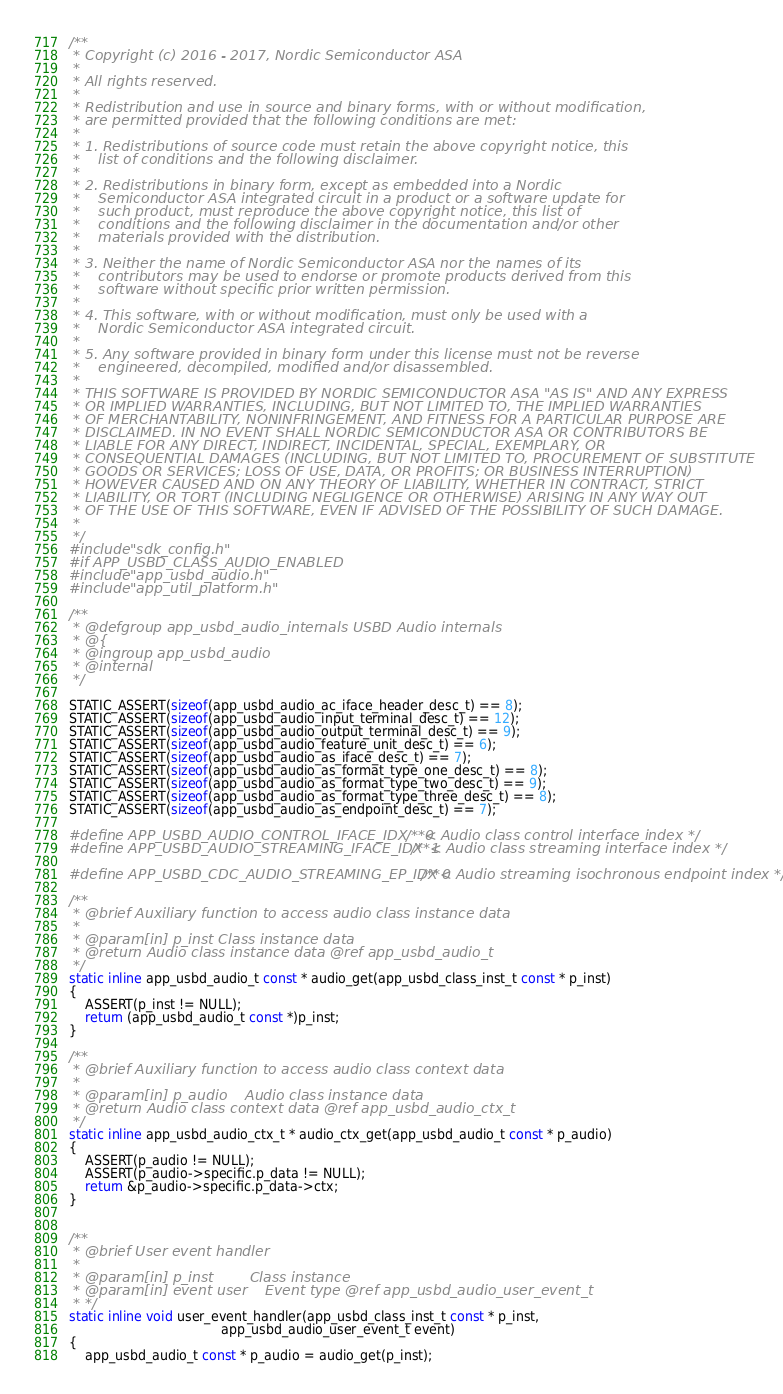<code> <loc_0><loc_0><loc_500><loc_500><_C_>/**
 * Copyright (c) 2016 - 2017, Nordic Semiconductor ASA
 * 
 * All rights reserved.
 * 
 * Redistribution and use in source and binary forms, with or without modification,
 * are permitted provided that the following conditions are met:
 * 
 * 1. Redistributions of source code must retain the above copyright notice, this
 *    list of conditions and the following disclaimer.
 * 
 * 2. Redistributions in binary form, except as embedded into a Nordic
 *    Semiconductor ASA integrated circuit in a product or a software update for
 *    such product, must reproduce the above copyright notice, this list of
 *    conditions and the following disclaimer in the documentation and/or other
 *    materials provided with the distribution.
 * 
 * 3. Neither the name of Nordic Semiconductor ASA nor the names of its
 *    contributors may be used to endorse or promote products derived from this
 *    software without specific prior written permission.
 * 
 * 4. This software, with or without modification, must only be used with a
 *    Nordic Semiconductor ASA integrated circuit.
 * 
 * 5. Any software provided in binary form under this license must not be reverse
 *    engineered, decompiled, modified and/or disassembled.
 * 
 * THIS SOFTWARE IS PROVIDED BY NORDIC SEMICONDUCTOR ASA "AS IS" AND ANY EXPRESS
 * OR IMPLIED WARRANTIES, INCLUDING, BUT NOT LIMITED TO, THE IMPLIED WARRANTIES
 * OF MERCHANTABILITY, NONINFRINGEMENT, AND FITNESS FOR A PARTICULAR PURPOSE ARE
 * DISCLAIMED. IN NO EVENT SHALL NORDIC SEMICONDUCTOR ASA OR CONTRIBUTORS BE
 * LIABLE FOR ANY DIRECT, INDIRECT, INCIDENTAL, SPECIAL, EXEMPLARY, OR
 * CONSEQUENTIAL DAMAGES (INCLUDING, BUT NOT LIMITED TO, PROCUREMENT OF SUBSTITUTE
 * GOODS OR SERVICES; LOSS OF USE, DATA, OR PROFITS; OR BUSINESS INTERRUPTION)
 * HOWEVER CAUSED AND ON ANY THEORY OF LIABILITY, WHETHER IN CONTRACT, STRICT
 * LIABILITY, OR TORT (INCLUDING NEGLIGENCE OR OTHERWISE) ARISING IN ANY WAY OUT
 * OF THE USE OF THIS SOFTWARE, EVEN IF ADVISED OF THE POSSIBILITY OF SUCH DAMAGE.
 * 
 */
#include "sdk_config.h"
#if APP_USBD_CLASS_AUDIO_ENABLED
#include "app_usbd_audio.h"
#include "app_util_platform.h"

/**
 * @defgroup app_usbd_audio_internals USBD Audio internals
 * @{
 * @ingroup app_usbd_audio
 * @internal
 */

STATIC_ASSERT(sizeof(app_usbd_audio_ac_iface_header_desc_t) == 8);
STATIC_ASSERT(sizeof(app_usbd_audio_input_terminal_desc_t) == 12);
STATIC_ASSERT(sizeof(app_usbd_audio_output_terminal_desc_t) == 9);
STATIC_ASSERT(sizeof(app_usbd_audio_feature_unit_desc_t) == 6);
STATIC_ASSERT(sizeof(app_usbd_audio_as_iface_desc_t) == 7);
STATIC_ASSERT(sizeof(app_usbd_audio_as_format_type_one_desc_t) == 8);
STATIC_ASSERT(sizeof(app_usbd_audio_as_format_type_two_desc_t) == 9);
STATIC_ASSERT(sizeof(app_usbd_audio_as_format_type_three_desc_t) == 8);
STATIC_ASSERT(sizeof(app_usbd_audio_as_endpoint_desc_t) == 7);

#define APP_USBD_AUDIO_CONTROL_IFACE_IDX    0  /**< Audio class control interface index */
#define APP_USBD_AUDIO_STREAMING_IFACE_IDX  1  /**< Audio class streaming interface index */

#define APP_USBD_CDC_AUDIO_STREAMING_EP_IDX 0  /**< Audio streaming isochronous endpoint index */

/**
 * @brief Auxiliary function to access audio class instance data
 *
 * @param[in] p_inst Class instance data
 * @return Audio class instance data @ref app_usbd_audio_t
 */
static inline app_usbd_audio_t const * audio_get(app_usbd_class_inst_t const * p_inst)
{
    ASSERT(p_inst != NULL);
    return (app_usbd_audio_t const *)p_inst;
}

/**
 * @brief Auxiliary function to access audio class context data
 *
 * @param[in] p_audio    Audio class instance data
 * @return Audio class context data @ref app_usbd_audio_ctx_t
 */
static inline app_usbd_audio_ctx_t * audio_ctx_get(app_usbd_audio_t const * p_audio)
{
    ASSERT(p_audio != NULL);
    ASSERT(p_audio->specific.p_data != NULL);
    return &p_audio->specific.p_data->ctx;
}


/**
 * @brief User event handler
 *
 * @param[in] p_inst        Class instance
 * @param[in] event user    Event type @ref app_usbd_audio_user_event_t
 * */
static inline void user_event_handler(app_usbd_class_inst_t const * p_inst,
                                      app_usbd_audio_user_event_t event)
{
    app_usbd_audio_t const * p_audio = audio_get(p_inst);</code> 